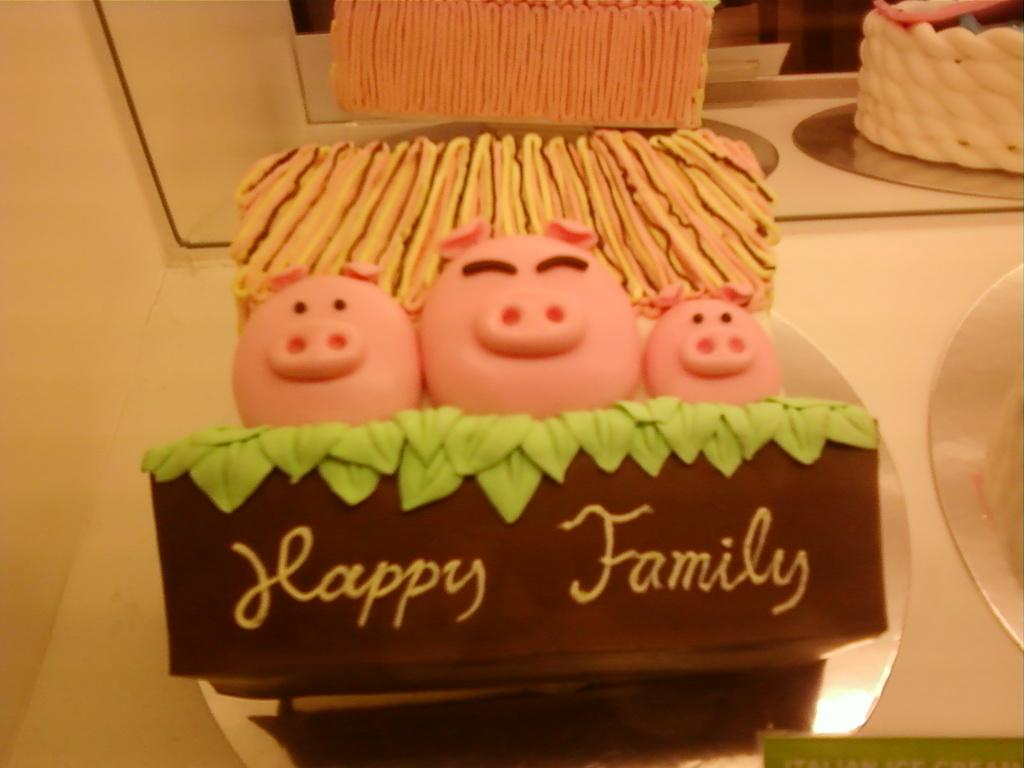What is the main subject of the image? There is a cake in the image. Where is the cake located? The cake is placed on a table. What can be seen in the background of the image? There is a mirror in the background of the image. What type of thread is used to decorate the cake in the image? There is no thread visible on the cake in the image. In which country is the cake being served in the image? The image does not provide any information about the country where the cake is being served. 